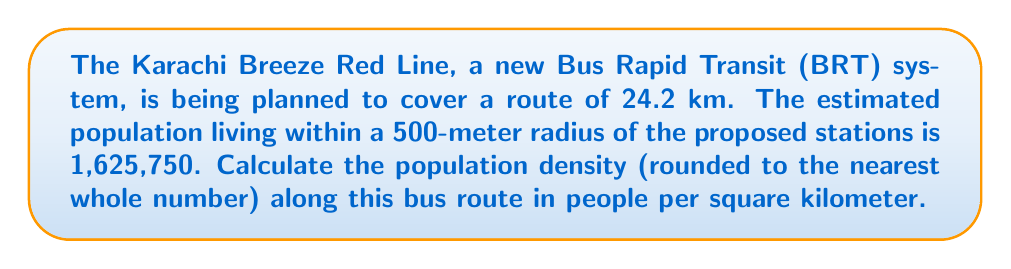Show me your answer to this math problem. To solve this problem, we need to follow these steps:

1. Calculate the area covered by the 500-meter radius around the bus route:
   The area is essentially a rectangle with rounded ends (like a stadium shape).
   
   Area = $24.2 \text{ km} \times 1 \text{ km} + \pi (0.5 \text{ km})^2$
   
   $$ A = 24.2 + \pi(0.25) $$
   $$ A = 24.2 + 0.7854 $$
   $$ A = 24.9854 \text{ km}^2 $$

2. Calculate the population density:
   Density = Population / Area

   $$ \text{Density} = \frac{1,625,750}{24.9854} $$
   $$ \text{Density} = 65,068.94 \text{ people/km}^2 $$

3. Round the result to the nearest whole number:
   65,068.94 rounds to 65,069 people/km²
Answer: 65,069 people/km² 